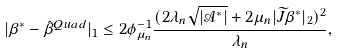<formula> <loc_0><loc_0><loc_500><loc_500>| \beta ^ { * } - \hat { \beta } ^ { Q u a d } | _ { 1 } \leq 2 \phi _ { \mu _ { n } } ^ { - 1 } \frac { ( 2 \lambda _ { n } \sqrt { | \mathcal { A } ^ { * } | } + 2 \mu _ { n } | \widetilde { J } \beta ^ { * } | _ { 2 } ) ^ { 2 } } { \lambda _ { n } } ,</formula> 